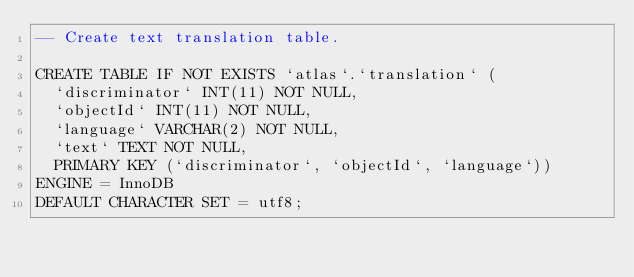Convert code to text. <code><loc_0><loc_0><loc_500><loc_500><_SQL_>-- Create text translation table.

CREATE TABLE IF NOT EXISTS `atlas`.`translation` (
  `discriminator` INT(11) NOT NULL,
  `objectId` INT(11) NOT NULL,
  `language` VARCHAR(2) NOT NULL,
  `text` TEXT NOT NULL,
  PRIMARY KEY (`discriminator`, `objectId`, `language`))
ENGINE = InnoDB
DEFAULT CHARACTER SET = utf8;
</code> 